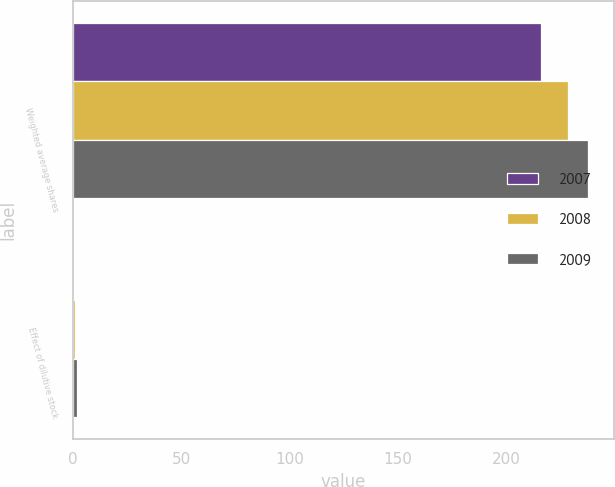<chart> <loc_0><loc_0><loc_500><loc_500><stacked_bar_chart><ecel><fcel>Weighted average shares<fcel>Effect of dilutive stock<nl><fcel>2007<fcel>215.8<fcel>0.8<nl><fcel>2008<fcel>228.3<fcel>1<nl><fcel>2009<fcel>237.5<fcel>2<nl></chart> 